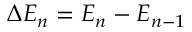<formula> <loc_0><loc_0><loc_500><loc_500>\Delta E _ { n } = E _ { n } - E _ { n - 1 }</formula> 